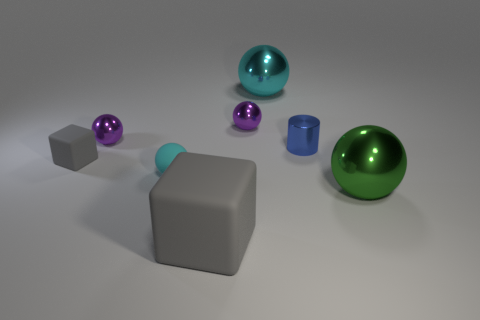There is a tiny object that is the same color as the big matte cube; what is it made of?
Make the answer very short. Rubber. Is the number of tiny cyan matte objects that are to the right of the large green thing the same as the number of tiny red rubber balls?
Offer a very short reply. Yes. Are there any gray rubber things in front of the small cyan object?
Keep it short and to the point. Yes. What number of metal things are cubes or tiny blocks?
Your response must be concise. 0. What number of cyan matte balls are behind the tiny gray matte thing?
Your answer should be compact. 0. Are there any gray matte things that have the same size as the blue shiny thing?
Offer a very short reply. Yes. Are there any other rubber blocks that have the same color as the large rubber cube?
Your response must be concise. Yes. What number of tiny matte cubes are the same color as the large block?
Ensure brevity in your answer.  1. There is a small cube; is its color the same as the shiny thing to the right of the tiny cylinder?
Offer a terse response. No. How many objects are either tiny purple balls or large objects that are behind the tiny cylinder?
Offer a terse response. 3. 